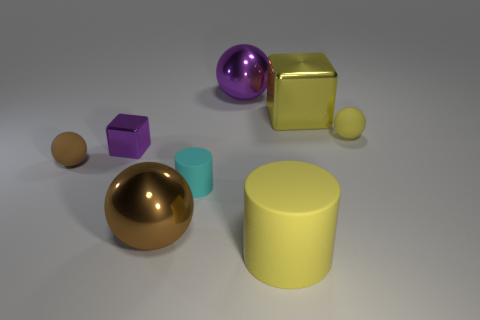There is a tiny object that is the same color as the large metallic cube; what is its material?
Give a very brief answer. Rubber. Do the yellow cube and the big yellow object in front of the brown metallic thing have the same material?
Your answer should be very brief. No. There is a small yellow object that is the same shape as the tiny brown object; what is it made of?
Offer a terse response. Rubber. Are there more yellow rubber objects that are behind the yellow matte cylinder than tiny yellow rubber things that are to the left of the brown metal sphere?
Keep it short and to the point. Yes. What shape is the tiny purple thing that is the same material as the large yellow block?
Give a very brief answer. Cube. How many other things are the same shape as the small brown rubber object?
Provide a short and direct response. 3. The yellow matte object that is behind the big brown object has what shape?
Give a very brief answer. Sphere. What color is the large rubber cylinder?
Offer a terse response. Yellow. How many other objects are there of the same size as the yellow shiny cube?
Your response must be concise. 3. There is a yellow object in front of the shiny object that is to the left of the brown metal sphere; what is it made of?
Keep it short and to the point. Rubber. 